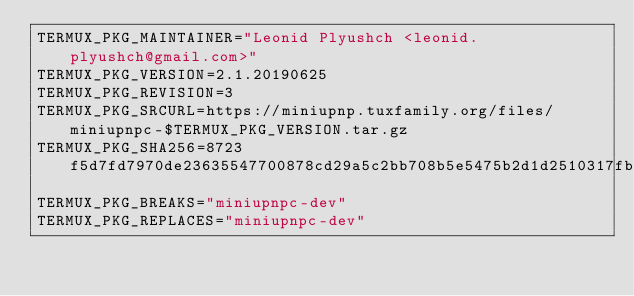<code> <loc_0><loc_0><loc_500><loc_500><_Bash_>TERMUX_PKG_MAINTAINER="Leonid Plyushch <leonid.plyushch@gmail.com>"
TERMUX_PKG_VERSION=2.1.20190625
TERMUX_PKG_REVISION=3
TERMUX_PKG_SRCURL=https://miniupnp.tuxfamily.org/files/miniupnpc-$TERMUX_PKG_VERSION.tar.gz
TERMUX_PKG_SHA256=8723f5d7fd7970de23635547700878cd29a5c2bb708b5e5475b2d1d2510317fb
TERMUX_PKG_BREAKS="miniupnpc-dev"
TERMUX_PKG_REPLACES="miniupnpc-dev"
</code> 